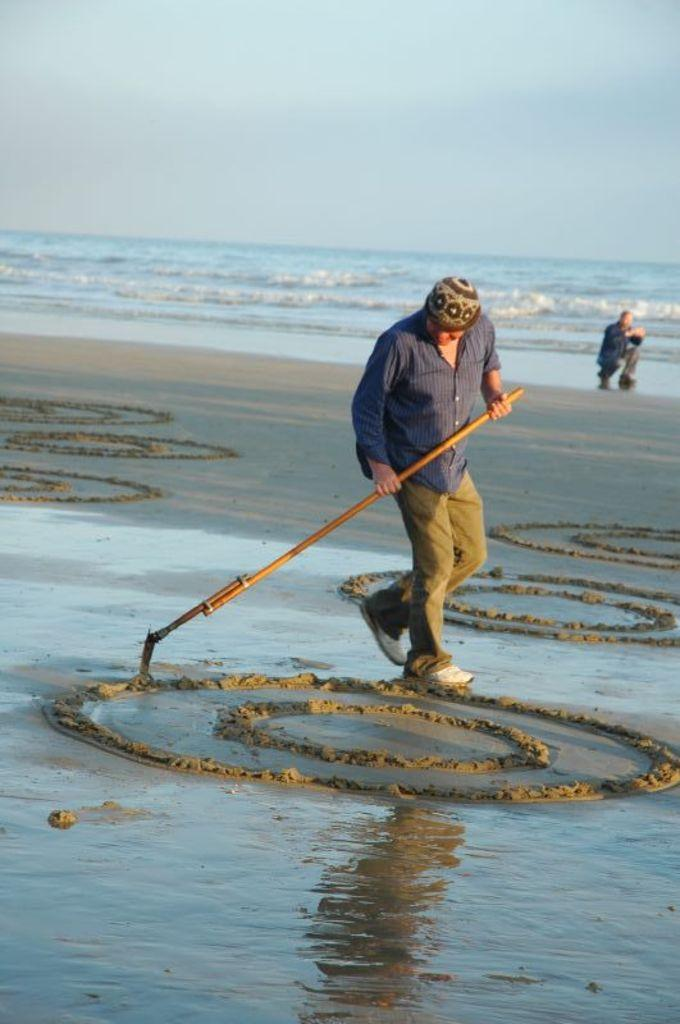What is the person holding in the image? The person is holding a stick in the image. What is the person doing with the stick? The person is drawing circles on the sand with the stick. Can you describe the other person visible in the image? There is another person visible in the image, but no specific details are provided about them. What is the setting of the image? The presence of sand and water suggests that the image is set near a beach or a body of water. What is the manager's role in the image? There is no mention of a manager or any management-related activities in the image. 